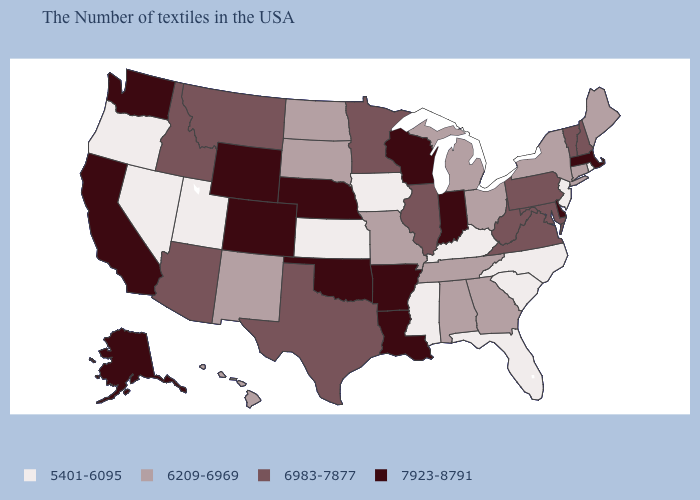Which states have the lowest value in the MidWest?
Quick response, please. Iowa, Kansas. Does Connecticut have a higher value than Colorado?
Keep it brief. No. Among the states that border Nebraska , which have the highest value?
Quick response, please. Wyoming, Colorado. What is the highest value in the USA?
Answer briefly. 7923-8791. Name the states that have a value in the range 6209-6969?
Give a very brief answer. Maine, Connecticut, New York, Ohio, Georgia, Michigan, Alabama, Tennessee, Missouri, South Dakota, North Dakota, New Mexico, Hawaii. Name the states that have a value in the range 6983-7877?
Concise answer only. New Hampshire, Vermont, Maryland, Pennsylvania, Virginia, West Virginia, Illinois, Minnesota, Texas, Montana, Arizona, Idaho. What is the lowest value in the South?
Short answer required. 5401-6095. Among the states that border New York , which have the lowest value?
Be succinct. New Jersey. What is the value of New Hampshire?
Write a very short answer. 6983-7877. What is the value of Missouri?
Be succinct. 6209-6969. Among the states that border Mississippi , which have the lowest value?
Be succinct. Alabama, Tennessee. What is the value of Connecticut?
Write a very short answer. 6209-6969. Name the states that have a value in the range 6209-6969?
Write a very short answer. Maine, Connecticut, New York, Ohio, Georgia, Michigan, Alabama, Tennessee, Missouri, South Dakota, North Dakota, New Mexico, Hawaii. What is the lowest value in the West?
Keep it brief. 5401-6095. Among the states that border Idaho , which have the lowest value?
Be succinct. Utah, Nevada, Oregon. 